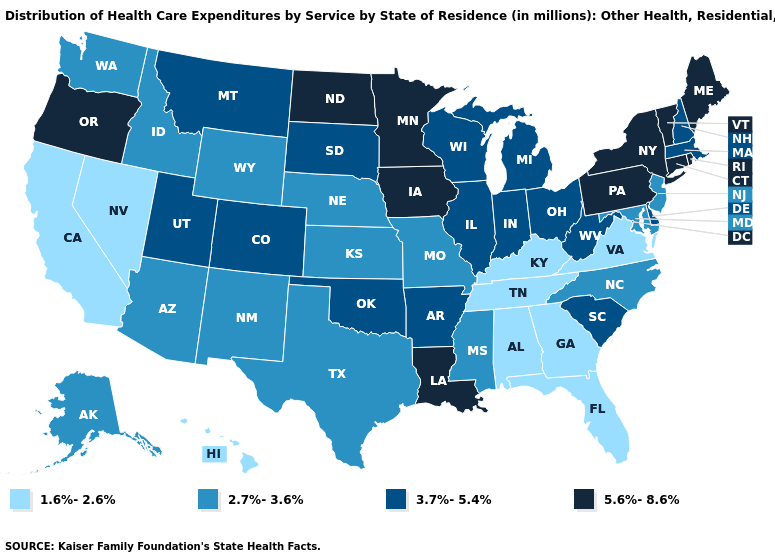Name the states that have a value in the range 5.6%-8.6%?
Answer briefly. Connecticut, Iowa, Louisiana, Maine, Minnesota, New York, North Dakota, Oregon, Pennsylvania, Rhode Island, Vermont. Does Oklahoma have the same value as Massachusetts?
Short answer required. Yes. What is the value of Oklahoma?
Give a very brief answer. 3.7%-5.4%. Among the states that border Rhode Island , which have the highest value?
Be succinct. Connecticut. Does Massachusetts have the lowest value in the USA?
Keep it brief. No. Does Michigan have a higher value than Arkansas?
Write a very short answer. No. What is the highest value in the South ?
Quick response, please. 5.6%-8.6%. What is the value of Florida?
Answer briefly. 1.6%-2.6%. What is the value of New Mexico?
Concise answer only. 2.7%-3.6%. Among the states that border California , which have the lowest value?
Be succinct. Nevada. Does Arkansas have the highest value in the South?
Give a very brief answer. No. Which states have the lowest value in the USA?
Quick response, please. Alabama, California, Florida, Georgia, Hawaii, Kentucky, Nevada, Tennessee, Virginia. What is the lowest value in the West?
Quick response, please. 1.6%-2.6%. Does Vermont have a higher value than Oregon?
Quick response, please. No. What is the value of Illinois?
Keep it brief. 3.7%-5.4%. 